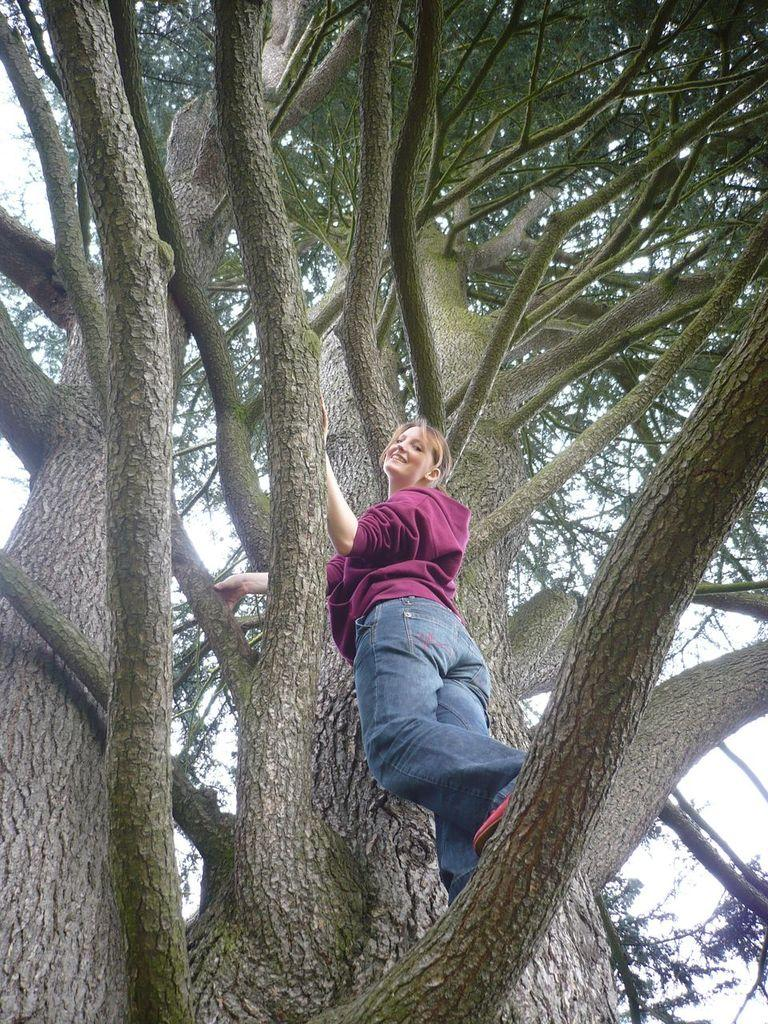Who is present in the image? There is a woman in the image. What is the woman wearing? The woman is wearing a jacket and jeans. What is the woman's facial expression? The woman is smiling. What is the woman standing on? The woman is standing on a tree trunk. What type of church can be seen in the background of the image? There is no church visible in the image; it features a woman standing on a tree trunk. What act is the woman performing on the tree trunk? The image does not depict the woman performing any specific act on the tree trunk; she is simply standing on it. 